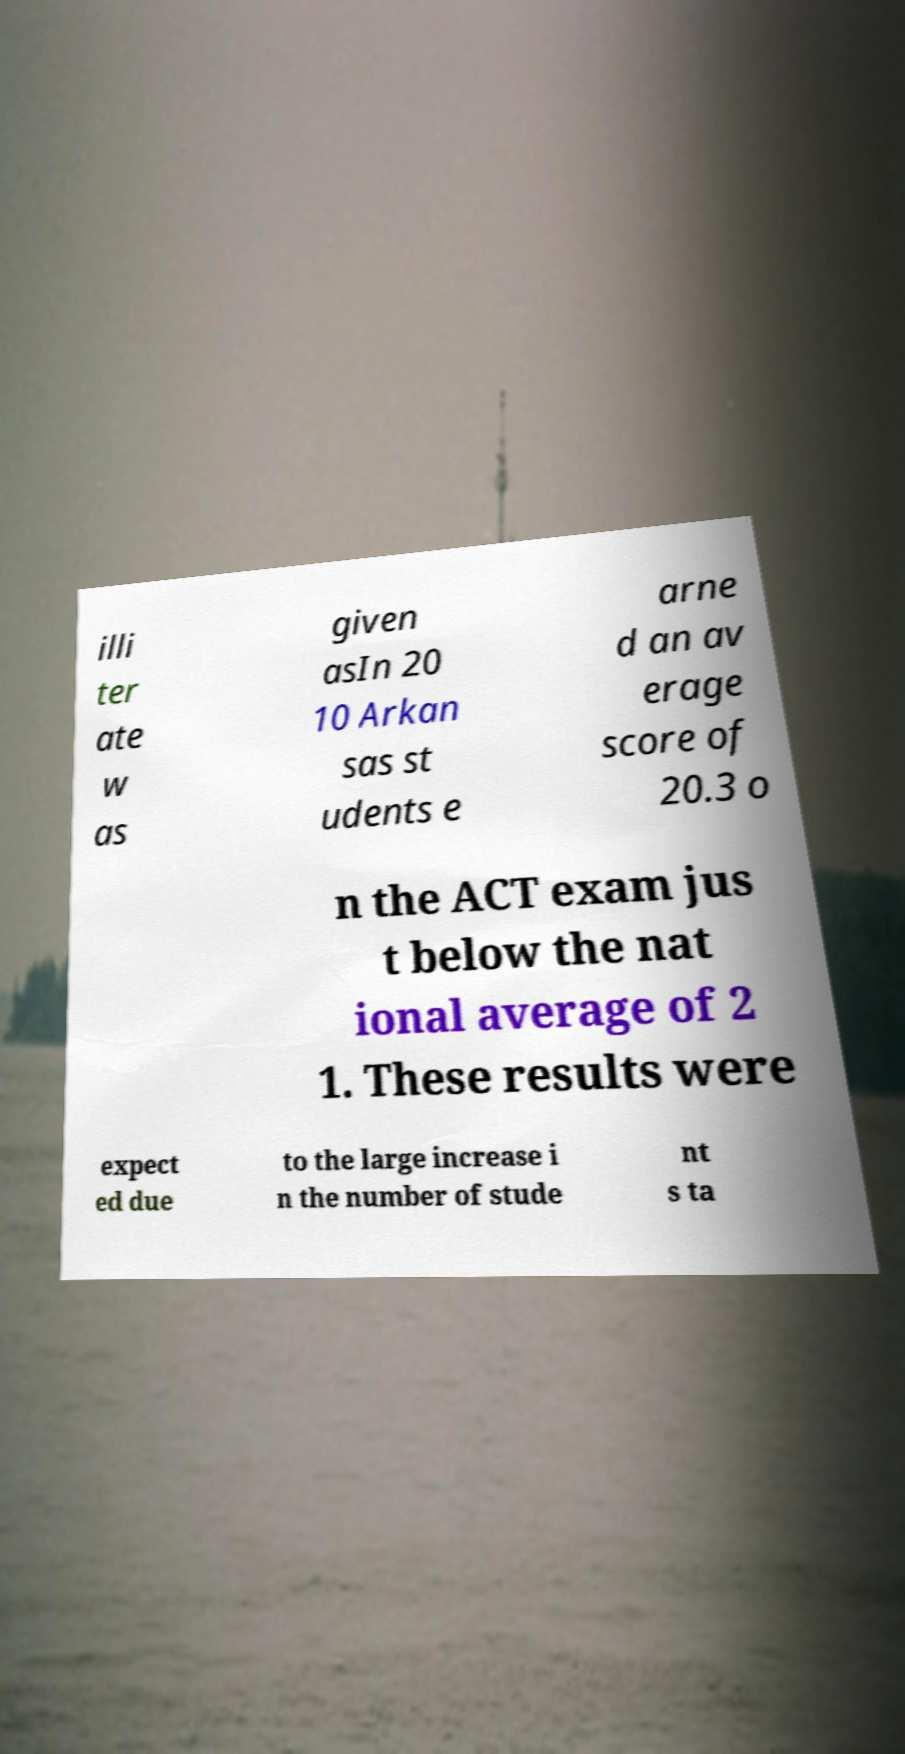Can you accurately transcribe the text from the provided image for me? illi ter ate w as given asIn 20 10 Arkan sas st udents e arne d an av erage score of 20.3 o n the ACT exam jus t below the nat ional average of 2 1. These results were expect ed due to the large increase i n the number of stude nt s ta 